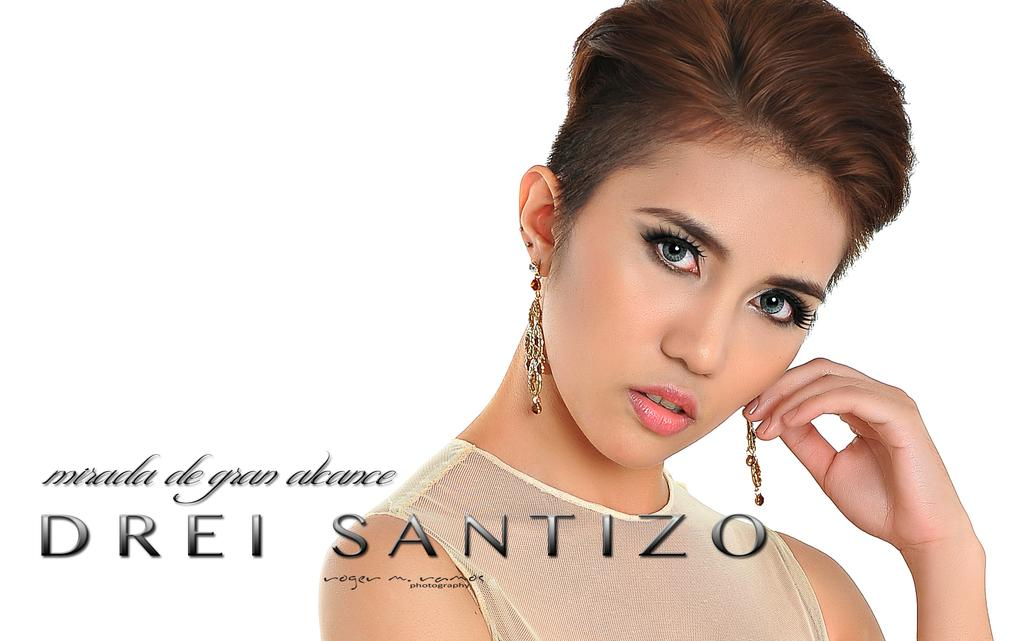Who is the main subject in the image? There is a lady in the image. What accessory is the lady wearing? The lady is wearing earrings. Is there any text or writing present in the image? Yes, there is text or writing on the image. What musical instrument is the lady playing in the image? There is no musical instrument present in the image, and the lady is not playing any instrument. 